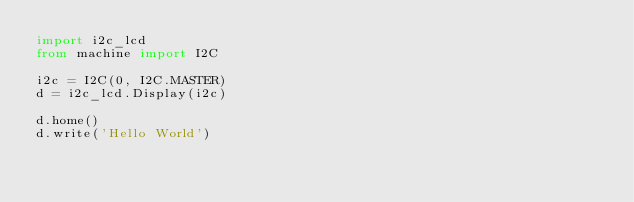<code> <loc_0><loc_0><loc_500><loc_500><_Python_>import i2c_lcd
from machine import I2C

i2c = I2C(0, I2C.MASTER)
d = i2c_lcd.Display(i2c)

d.home()
d.write('Hello World')
</code> 